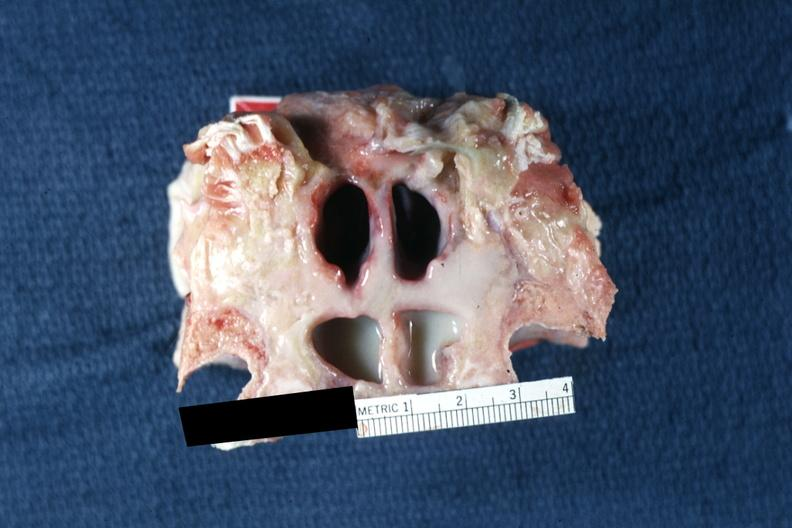does all the fat necrosis show frontal sinuses inflammation and pus well shown?
Answer the question using a single word or phrase. No 